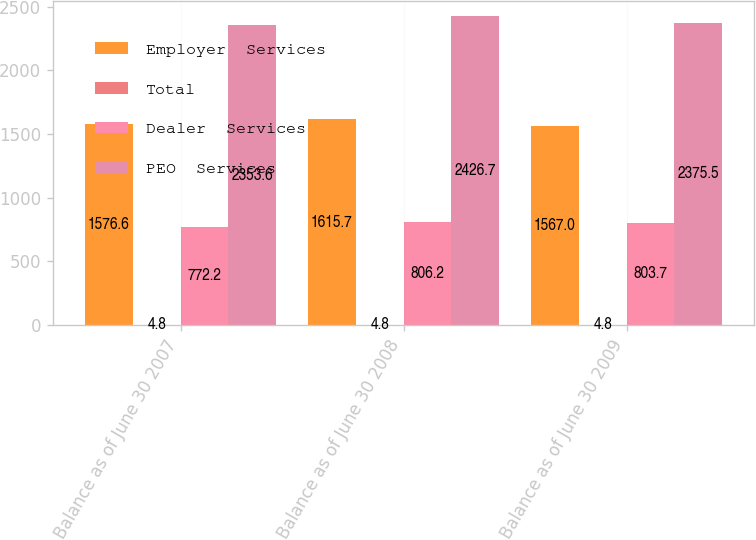Convert chart. <chart><loc_0><loc_0><loc_500><loc_500><stacked_bar_chart><ecel><fcel>Balance as of June 30 2007<fcel>Balance as of June 30 2008<fcel>Balance as of June 30 2009<nl><fcel>Employer  Services<fcel>1576.6<fcel>1615.7<fcel>1567<nl><fcel>Total<fcel>4.8<fcel>4.8<fcel>4.8<nl><fcel>Dealer  Services<fcel>772.2<fcel>806.2<fcel>803.7<nl><fcel>PEO  Services<fcel>2353.6<fcel>2426.7<fcel>2375.5<nl></chart> 